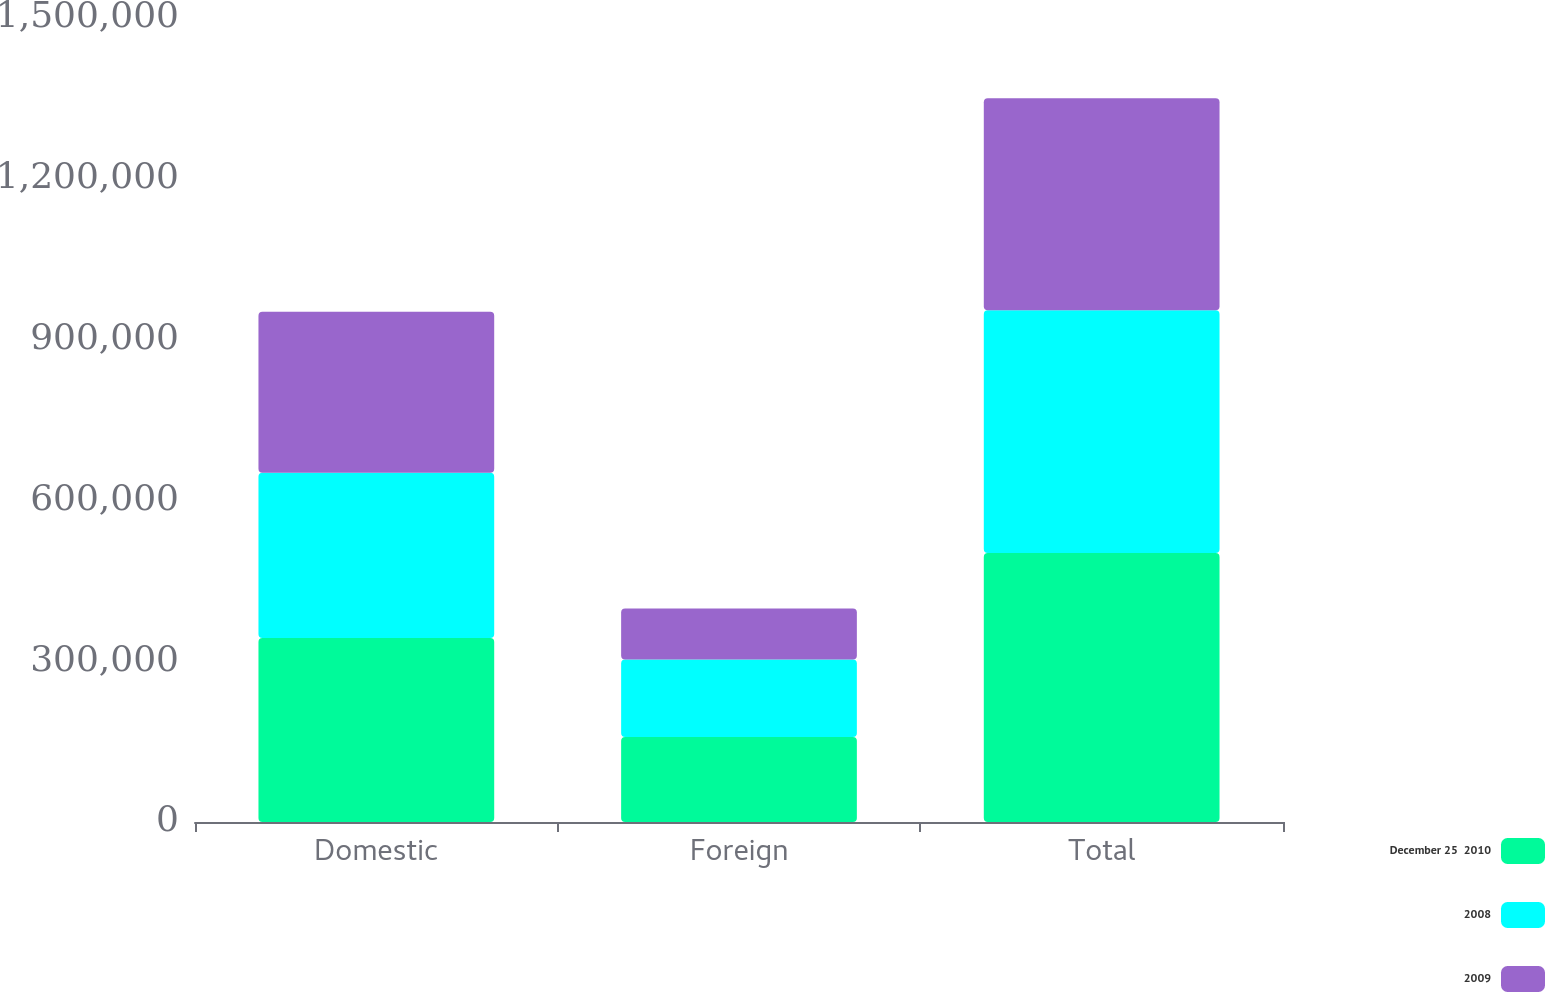Convert chart. <chart><loc_0><loc_0><loc_500><loc_500><stacked_bar_chart><ecel><fcel>Domestic<fcel>Foreign<fcel>Total<nl><fcel>December 25  2010<fcel>343502<fcel>158533<fcel>502035<nl><fcel>2008<fcel>308238<fcel>144482<fcel>452720<nl><fcel>2009<fcel>300227<fcel>95222<fcel>395449<nl></chart> 